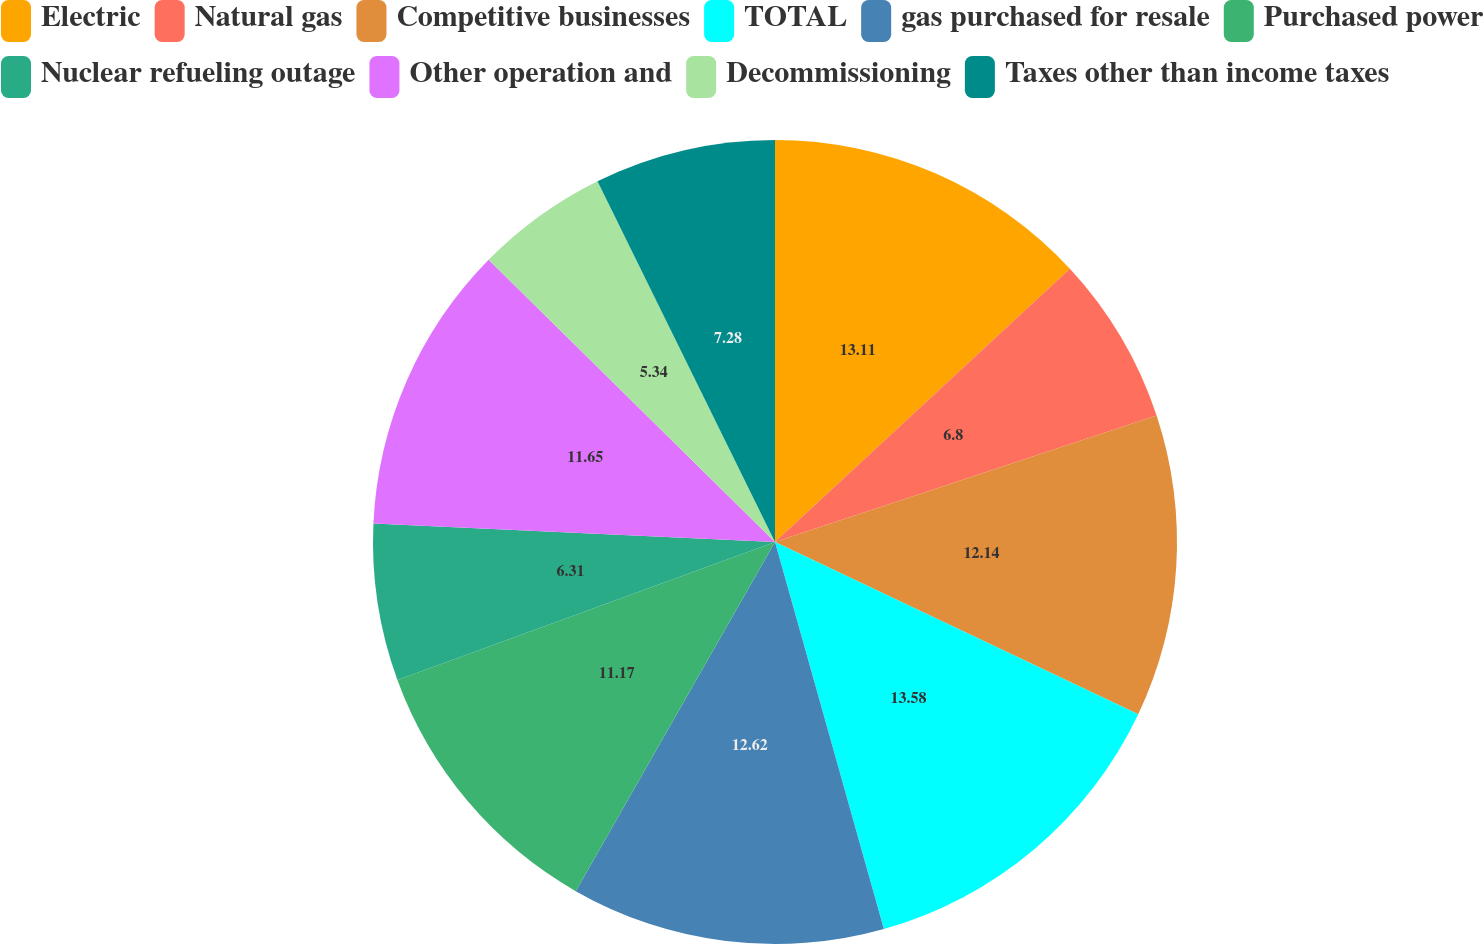Convert chart to OTSL. <chart><loc_0><loc_0><loc_500><loc_500><pie_chart><fcel>Electric<fcel>Natural gas<fcel>Competitive businesses<fcel>TOTAL<fcel>gas purchased for resale<fcel>Purchased power<fcel>Nuclear refueling outage<fcel>Other operation and<fcel>Decommissioning<fcel>Taxes other than income taxes<nl><fcel>13.11%<fcel>6.8%<fcel>12.14%<fcel>13.59%<fcel>12.62%<fcel>11.17%<fcel>6.31%<fcel>11.65%<fcel>5.34%<fcel>7.28%<nl></chart> 